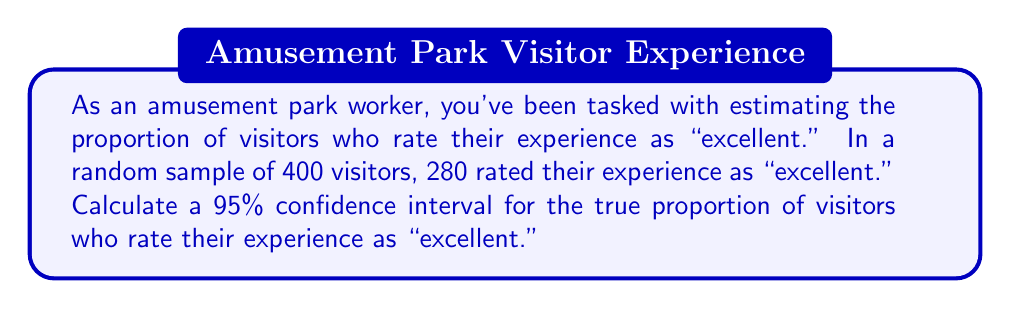Can you solve this math problem? Let's approach this step-by-step:

1) First, we need to identify our values:
   - Sample size: $n = 400$
   - Number of successes: $x = 280$
   - Confidence level: 95% (so $z^* = 1.96$)

2) Calculate the sample proportion:
   $\hat{p} = \frac{x}{n} = \frac{280}{400} = 0.7$

3) Calculate the standard error:
   $SE = \sqrt{\frac{\hat{p}(1-\hat{p})}{n}} = \sqrt{\frac{0.7(1-0.7)}{400}} = \sqrt{\frac{0.21}{400}} = 0.0229$

4) The formula for the confidence interval is:
   $\hat{p} \pm z^* \times SE$

5) Plugging in our values:
   $0.7 \pm 1.96 \times 0.0229$

6) Calculating:
   $0.7 \pm 0.0449$

7) Therefore, the confidence interval is:
   $(0.7 - 0.0449, 0.7 + 0.0449) = (0.6551, 0.7449)$

This means we can be 95% confident that the true proportion of visitors who rate their experience as "excellent" is between 0.6551 and 0.7449, or approximately between 65.51% and 74.49%.
Answer: (0.6551, 0.7449) 